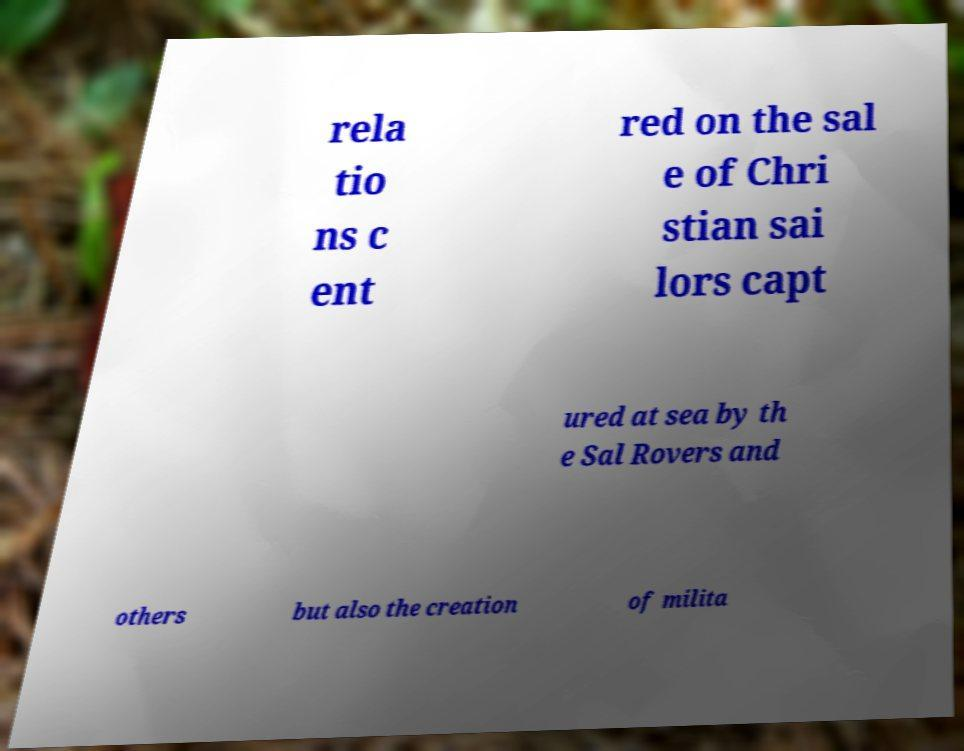I need the written content from this picture converted into text. Can you do that? rela tio ns c ent red on the sal e of Chri stian sai lors capt ured at sea by th e Sal Rovers and others but also the creation of milita 